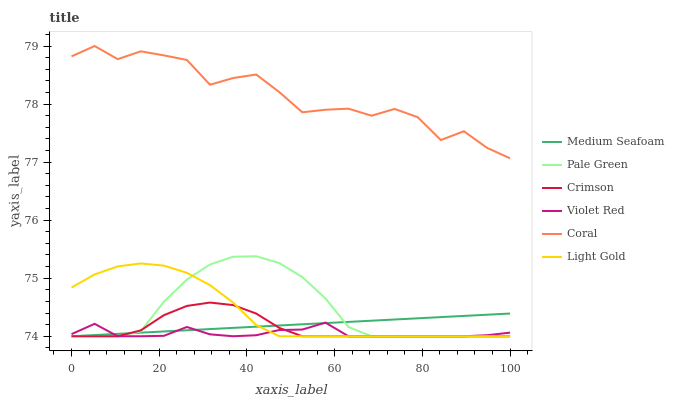Does Violet Red have the minimum area under the curve?
Answer yes or no. Yes. Does Coral have the maximum area under the curve?
Answer yes or no. Yes. Does Pale Green have the minimum area under the curve?
Answer yes or no. No. Does Pale Green have the maximum area under the curve?
Answer yes or no. No. Is Medium Seafoam the smoothest?
Answer yes or no. Yes. Is Coral the roughest?
Answer yes or no. Yes. Is Pale Green the smoothest?
Answer yes or no. No. Is Pale Green the roughest?
Answer yes or no. No. Does Coral have the lowest value?
Answer yes or no. No. Does Pale Green have the highest value?
Answer yes or no. No. Is Light Gold less than Coral?
Answer yes or no. Yes. Is Coral greater than Medium Seafoam?
Answer yes or no. Yes. Does Light Gold intersect Coral?
Answer yes or no. No. 